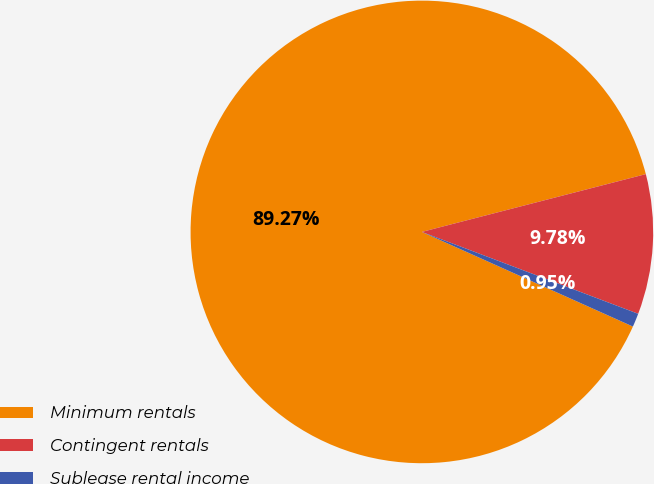Convert chart to OTSL. <chart><loc_0><loc_0><loc_500><loc_500><pie_chart><fcel>Minimum rentals<fcel>Contingent rentals<fcel>Sublease rental income<nl><fcel>89.27%<fcel>9.78%<fcel>0.95%<nl></chart> 